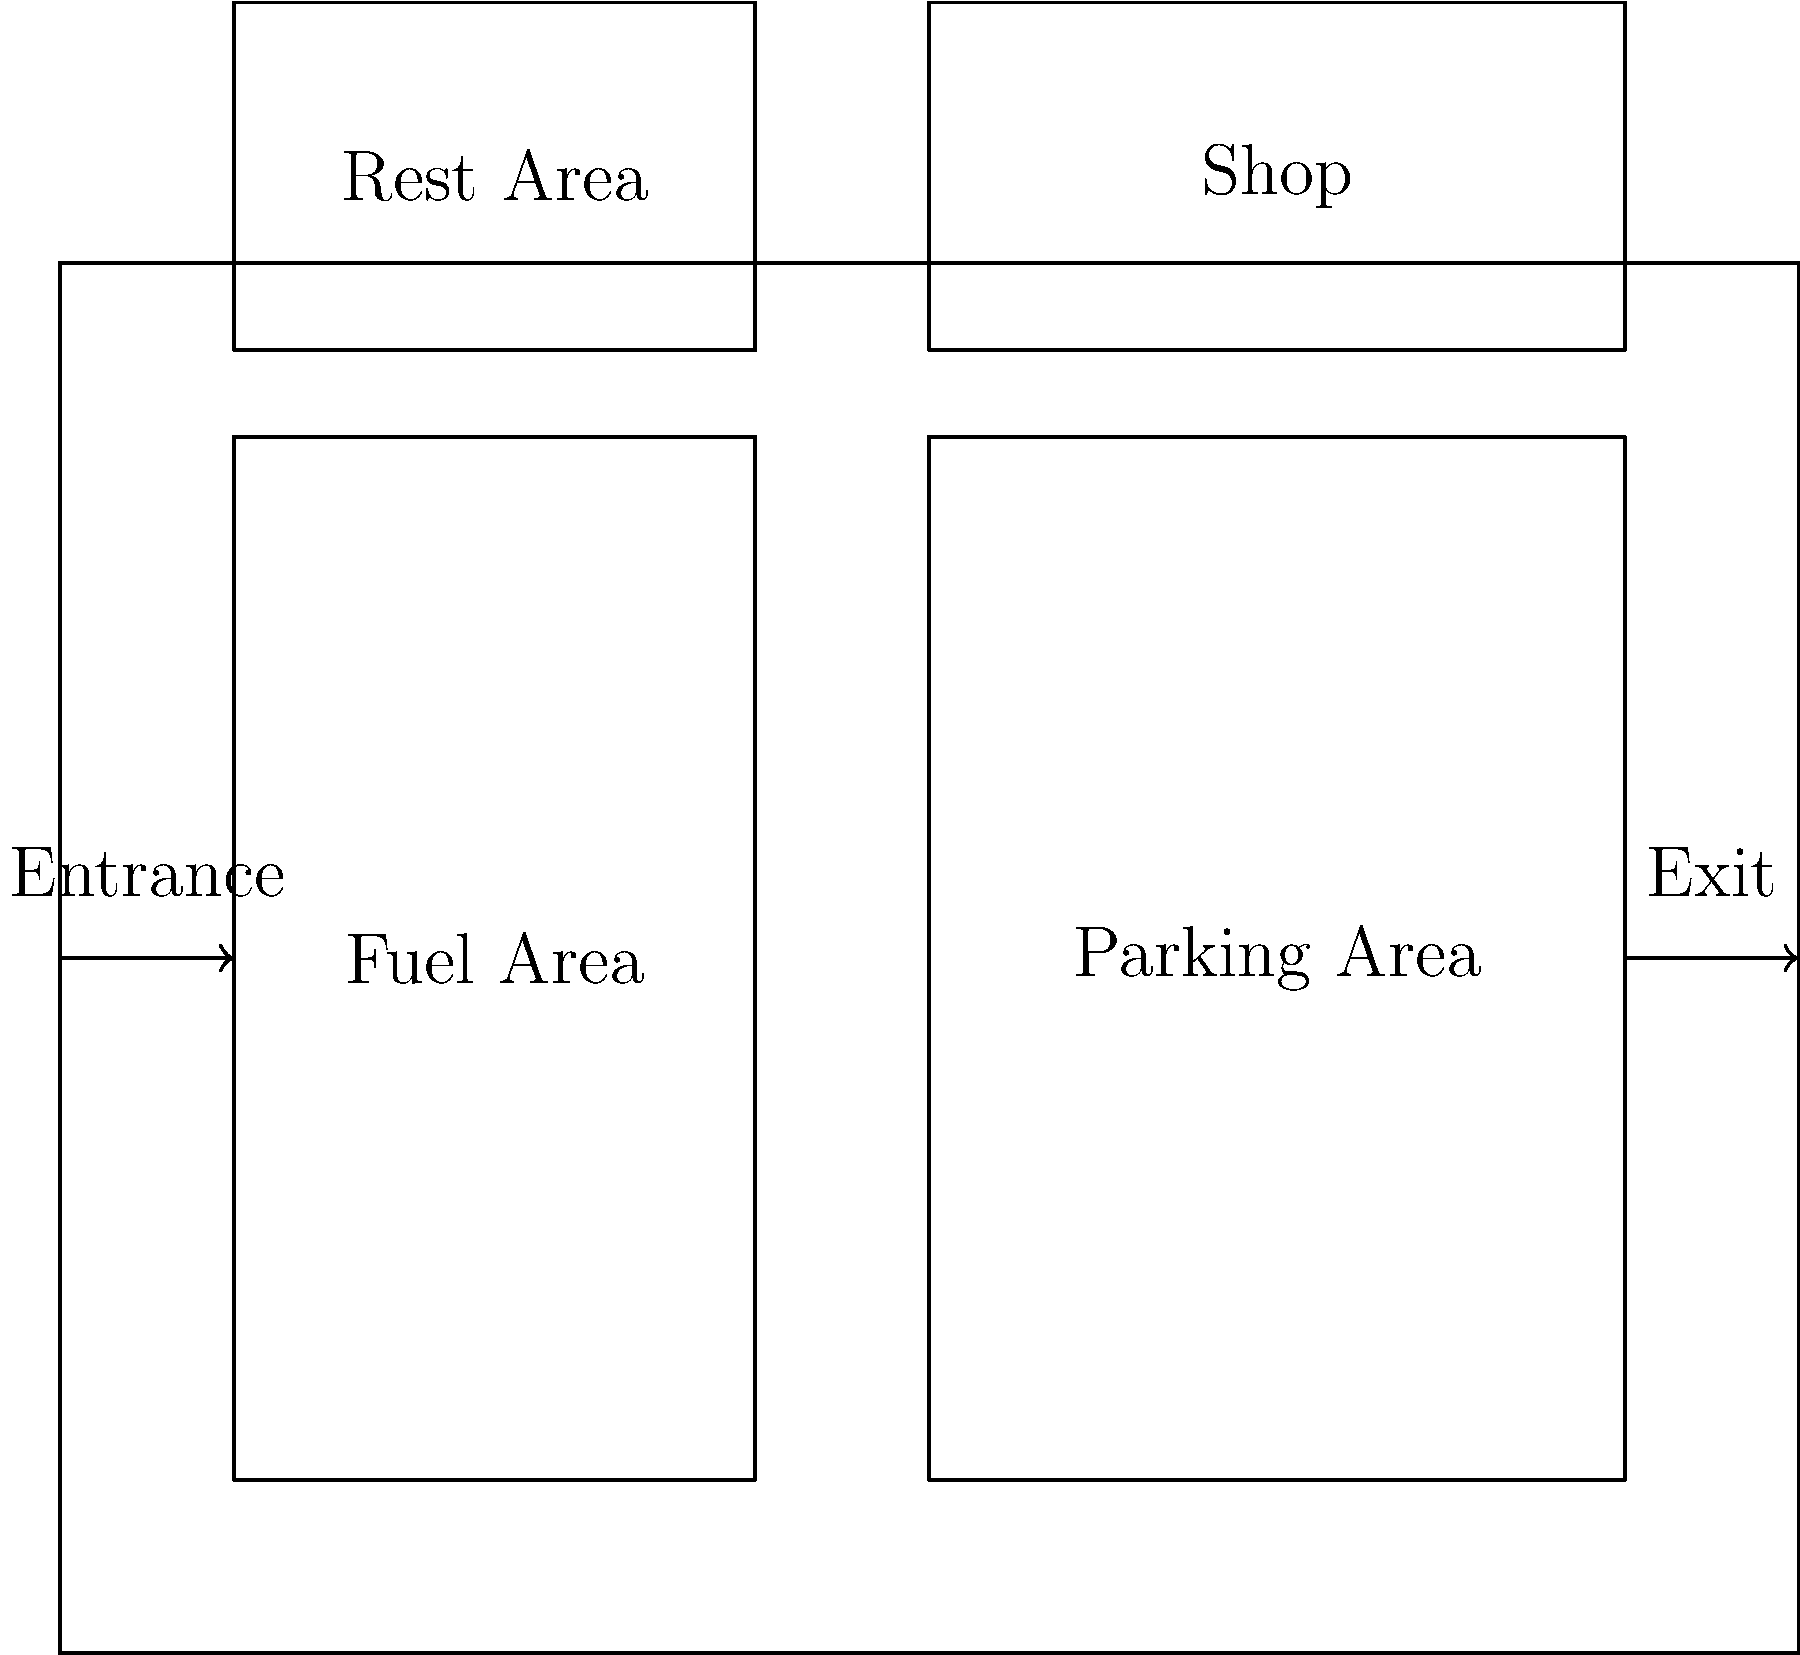Based on the floor plan diagram of a truck stop, which area is strategically placed closest to both the entrance and exit to maximize efficiency for drivers making quick stops? To determine the most strategically placed area for quick stops, we need to analyze the layout:

1. Identify the entrance and exit:
   - The entrance is on the left side of the diagram.
   - The exit is on the right side of the diagram.

2. Examine the locations of different areas:
   - The Fuel Area is on the left side, closest to the entrance.
   - The Parking Area is on the right side, closest to the exit.
   - The Rest Area and Shop are at the top of the diagram, further from both entrance and exit.

3. Consider the purpose of quick stops:
   - Drivers making quick stops are likely to need fuel more than other services.
   - The Fuel Area should be easily accessible for efficiency.

4. Analyze the Fuel Area's position:
   - It is directly adjacent to the entrance.
   - Drivers can easily pull in, fuel up, and proceed to the exit without navigating through other areas.

5. Compare with other areas:
   - The Parking Area, while close to the exit, requires drivers to pass through the entire facility.
   - The Rest Area and Shop are furthest from both entrance and exit, making them less suitable for quick stops.

Therefore, the Fuel Area is strategically placed closest to both the entrance and exit, maximizing efficiency for drivers making quick stops.
Answer: Fuel Area 